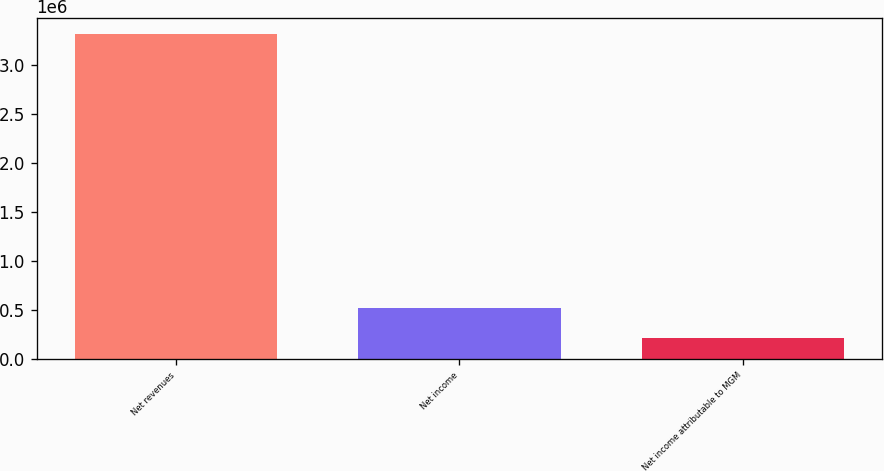Convert chart. <chart><loc_0><loc_0><loc_500><loc_500><bar_chart><fcel>Net revenues<fcel>Net income<fcel>Net income attributable to MGM<nl><fcel>3.31693e+06<fcel>521737<fcel>211160<nl></chart> 